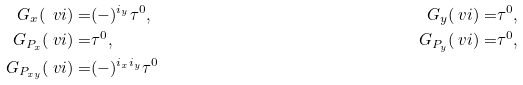Convert formula to latex. <formula><loc_0><loc_0><loc_500><loc_500>G _ { x } ( \ v i ) = & ( - ) ^ { i _ { y } } \tau ^ { 0 } , & G _ { y } ( \ v i ) = & \tau ^ { 0 } , \\ G _ { P _ { x } } ( \ v i ) = & \tau ^ { 0 } , & G _ { P _ { y } } ( \ v i ) = & \tau ^ { 0 } , \\ G _ { P _ { x y } } ( \ v i ) = & ( - ) ^ { i _ { x } i _ { y } } \tau ^ { 0 }</formula> 